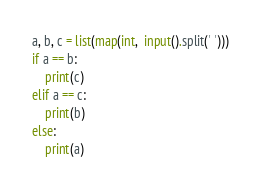<code> <loc_0><loc_0><loc_500><loc_500><_Python_>a, b, c = list(map(int,  input().split(' ')))
if a == b:
    print(c)
elif a == c:
    print(b)
else:
    print(a)

</code> 